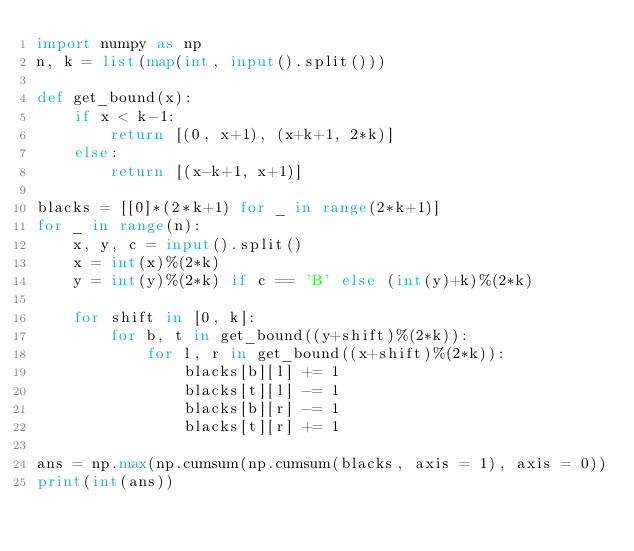Convert code to text. <code><loc_0><loc_0><loc_500><loc_500><_Python_>import numpy as np
n, k = list(map(int, input().split()))

def get_bound(x):
    if x < k-1:
        return [(0, x+1), (x+k+1, 2*k)]
    else:
        return [(x-k+1, x+1)]

blacks = [[0]*(2*k+1) for _ in range(2*k+1)]
for _ in range(n):
    x, y, c = input().split()
    x = int(x)%(2*k)
    y = int(y)%(2*k) if c == 'B' else (int(y)+k)%(2*k)

    for shift in [0, k]:
        for b, t in get_bound((y+shift)%(2*k)):
            for l, r in get_bound((x+shift)%(2*k)):
                blacks[b][l] += 1
                blacks[t][l] -= 1
                blacks[b][r] -= 1
                blacks[t][r] += 1
        
ans = np.max(np.cumsum(np.cumsum(blacks, axis = 1), axis = 0))
print(int(ans))
</code> 